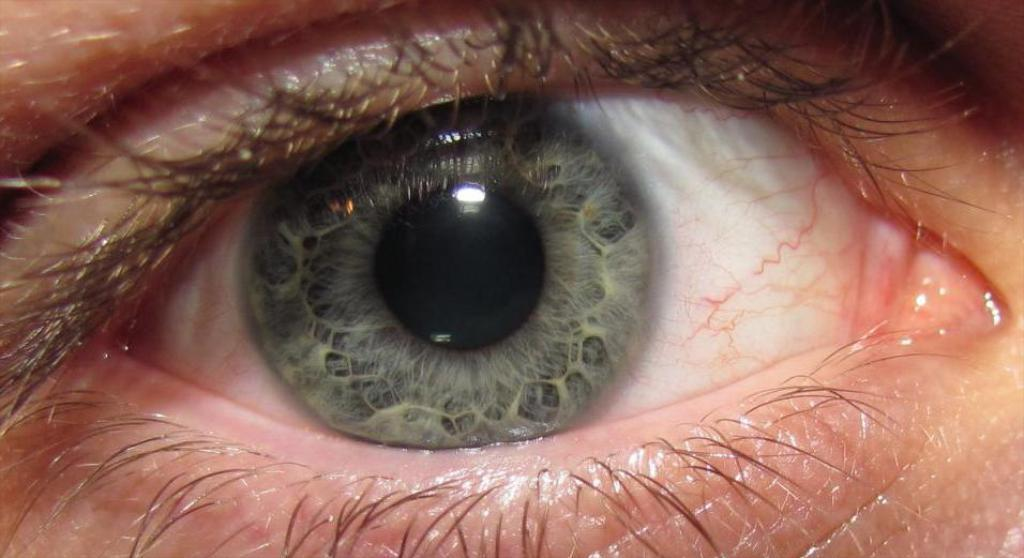What is the main subject of the image? The main subject of the image is the eye of a human being. Can you describe the eye in the image? The eye appears to be a close-up view, showing details such as the iris, pupil, and eyelashes. What type of theory can be seen being tested in the image? There is no theory or testing visible in the image; it is a close-up view of a human eye. How does the snow affect the friction between the eye and the surrounding environment in the image? There is no snow or friction present in the image; it is a close-up view of a human eye. 